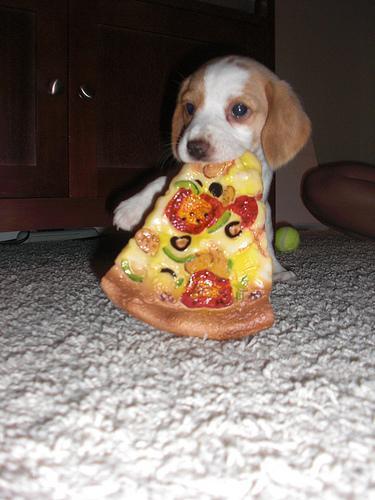How many dogs?
Give a very brief answer. 1. 